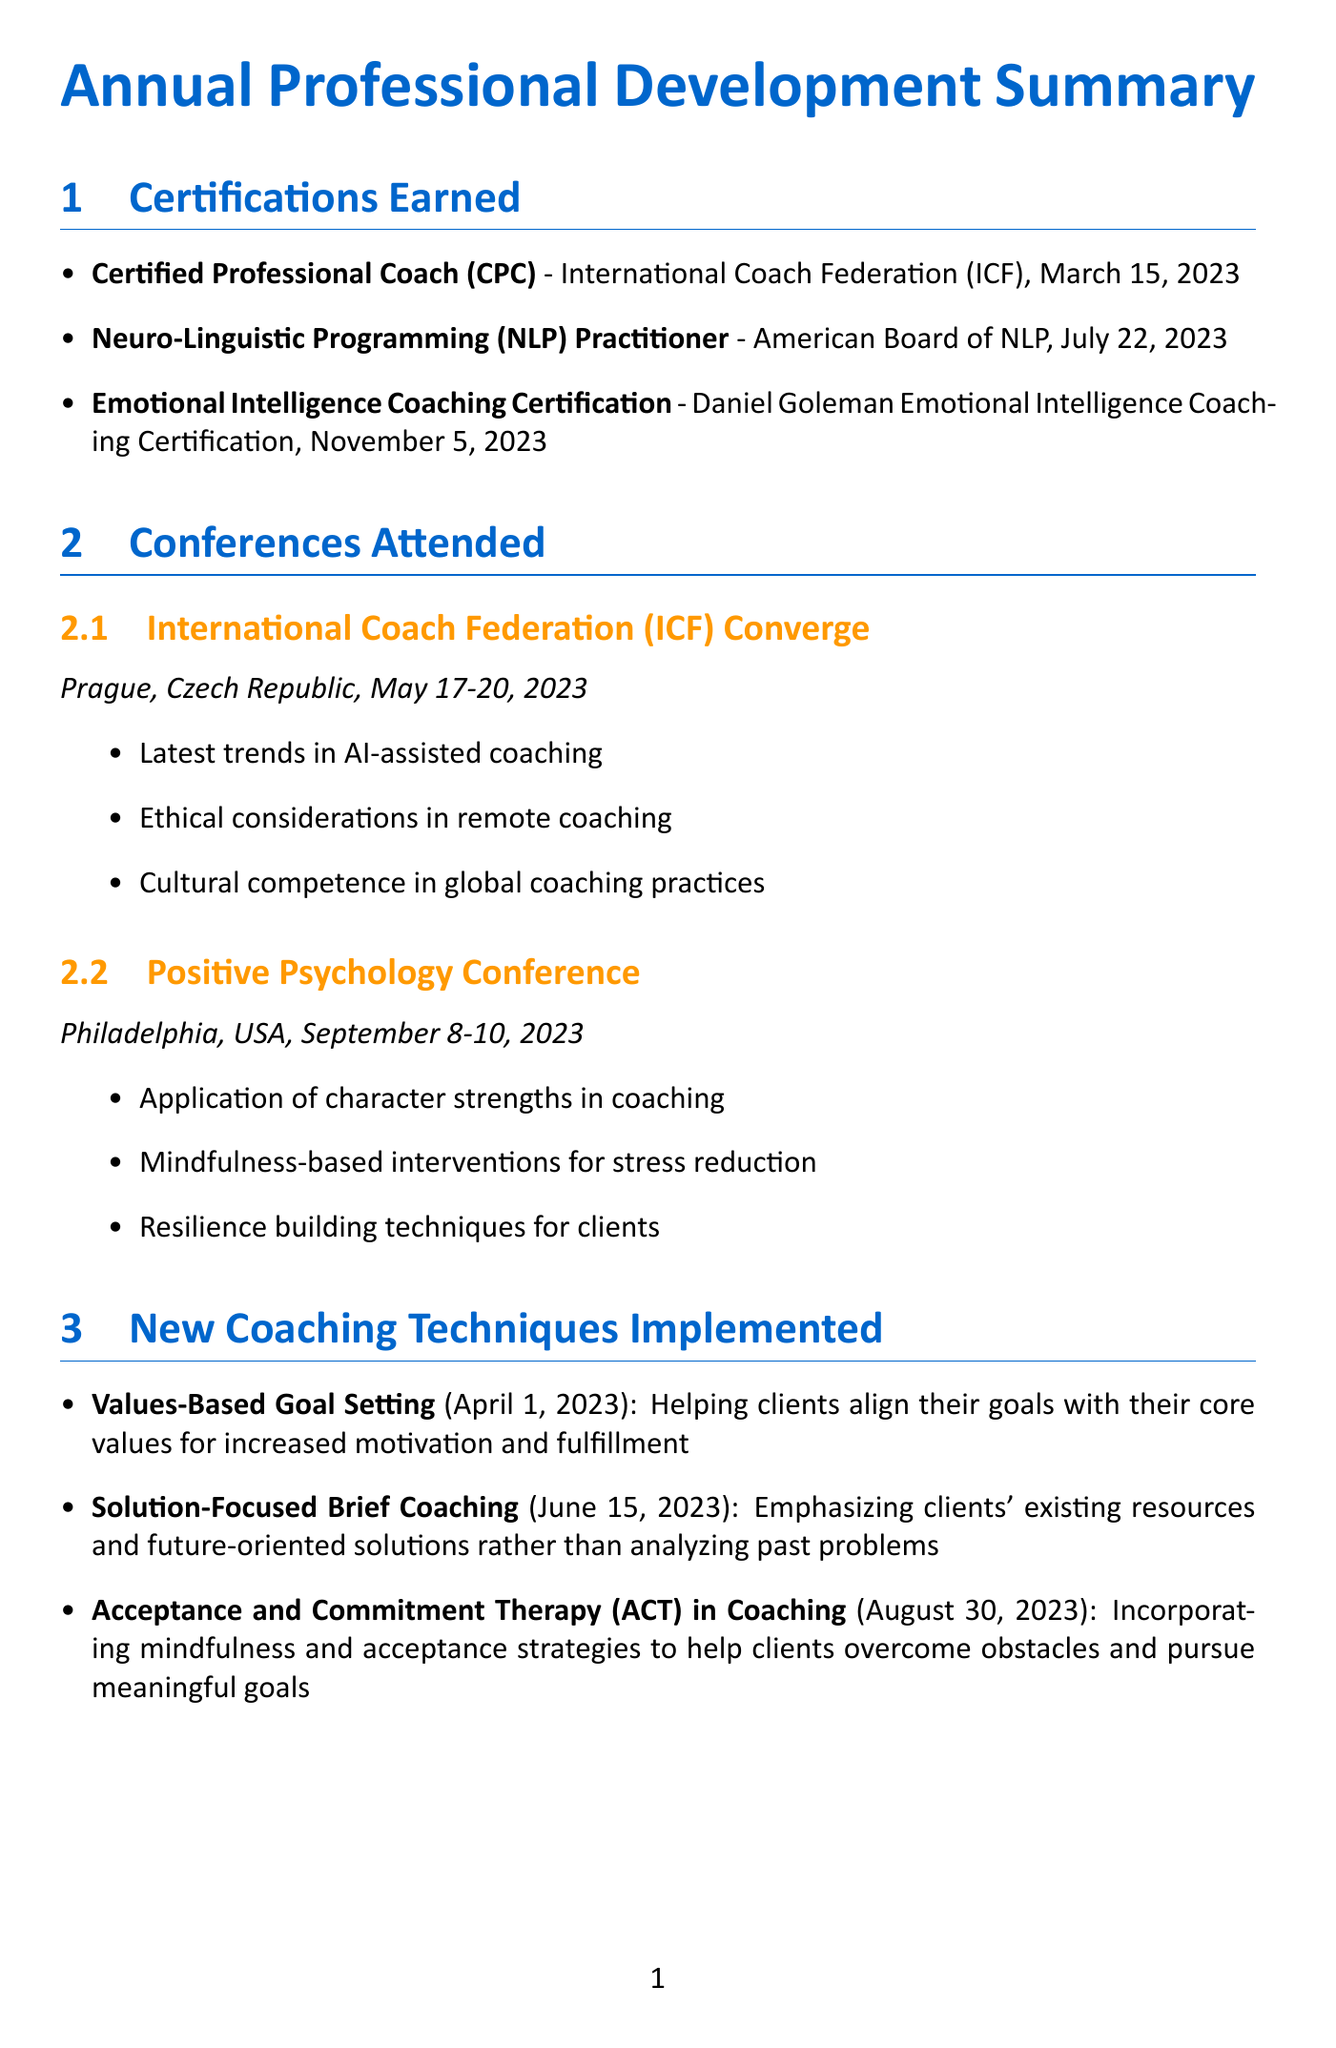What is the latest certification earned? The latest certification earned is the Emotional Intelligence Coaching Certification, completed on November 5, 2023.
Answer: Emotional Intelligence Coaching Certification Who issued the Certified Professional Coach certification? The Certified Professional Coach certification was issued by the International Coach Federation (ICF).
Answer: International Coach Federation (ICF) What conference was attended in Prague? The conference attended in Prague was the International Coach Federation (ICF) Converge.
Answer: International Coach Federation (ICF) Converge How many key takeaways were noted from the Positive Psychology Conference? There were three key takeaways noted from the Positive Psychology Conference.
Answer: 3 What new coaching technique was implemented on August 30, 2023? The new coaching technique implemented on August 30, 2023, is Acceptance and Commitment Therapy (ACT) in Coaching.
Answer: Acceptance and Commitment Therapy (ACT) in Coaching Which podcast focuses on personal development and life coaching concepts? The podcast that focuses on personal development and life coaching concepts is The Life Coach School Podcast.
Answer: The Life Coach School Podcast How many professional development goals are outlined for next year? There are five professional development goals outlined for next year.
Answer: 5 What technique emphasizes existing resources in clients? The technique that emphasizes existing resources in clients is Solution-Focused Brief Coaching.
Answer: Solution-Focused Brief Coaching Who hosts the podcast "Coaching for Leaders"? The podcast "Coaching for Leaders" is hosted by Dave Stachowiak.
Answer: Dave Stachowiak 